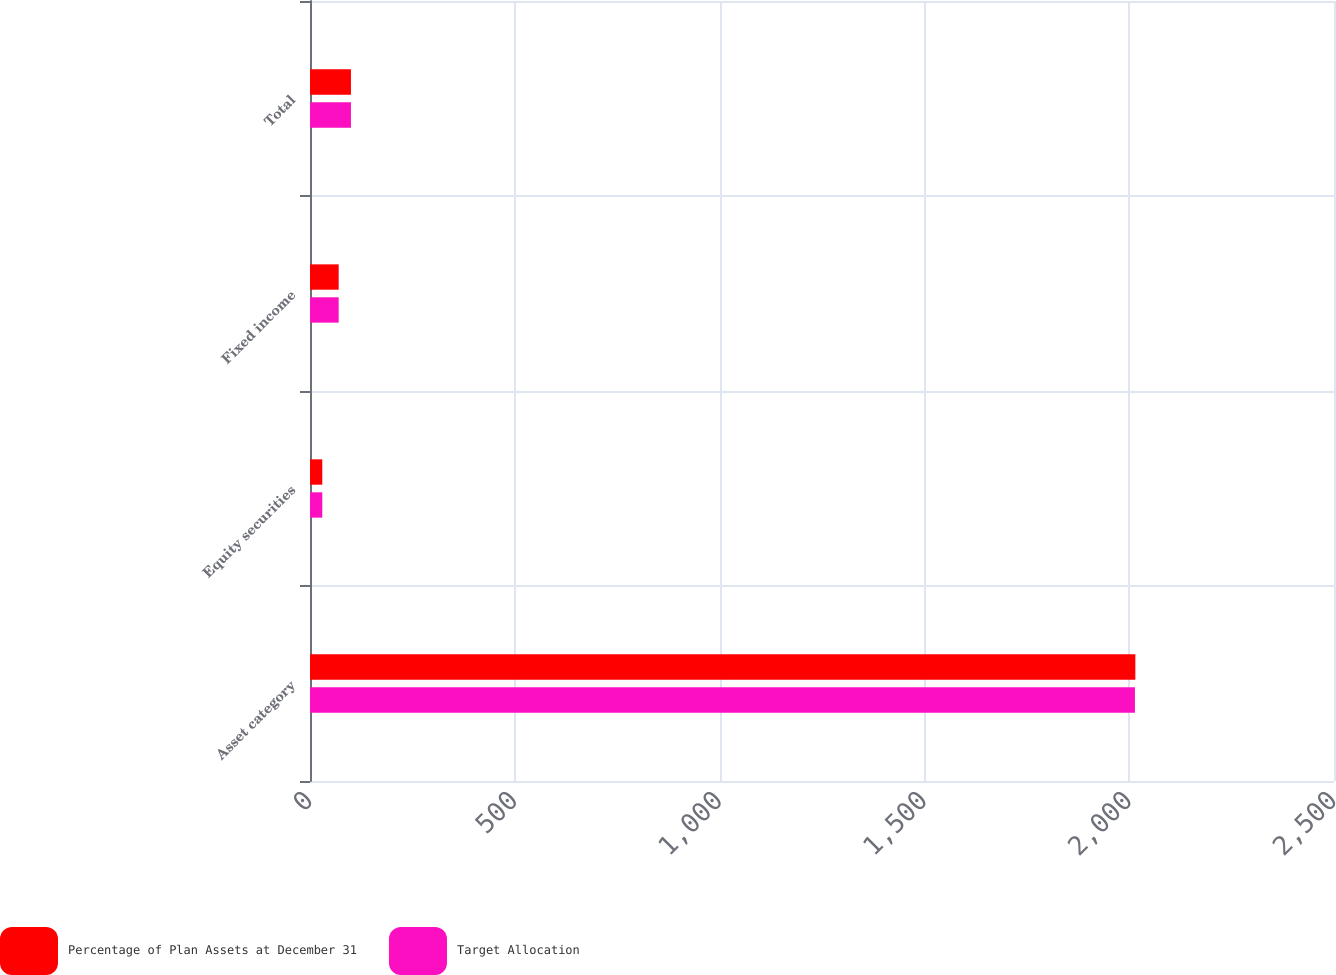Convert chart. <chart><loc_0><loc_0><loc_500><loc_500><stacked_bar_chart><ecel><fcel>Asset category<fcel>Equity securities<fcel>Fixed income<fcel>Total<nl><fcel>Percentage of Plan Assets at December 31<fcel>2015<fcel>30<fcel>70<fcel>100<nl><fcel>Target Allocation<fcel>2014<fcel>30<fcel>70<fcel>100<nl></chart> 